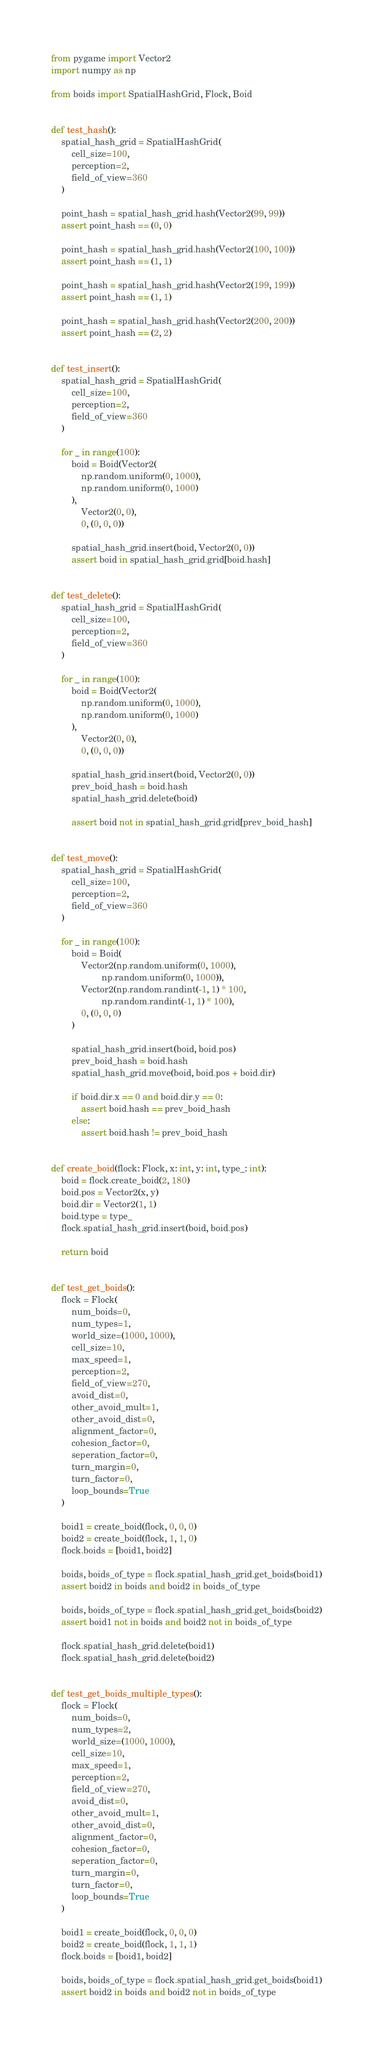<code> <loc_0><loc_0><loc_500><loc_500><_Python_>from pygame import Vector2
import numpy as np

from boids import SpatialHashGrid, Flock, Boid


def test_hash():
    spatial_hash_grid = SpatialHashGrid(
        cell_size=100,
        perception=2,
        field_of_view=360
    )

    point_hash = spatial_hash_grid.hash(Vector2(99, 99))
    assert point_hash == (0, 0)

    point_hash = spatial_hash_grid.hash(Vector2(100, 100))
    assert point_hash == (1, 1)

    point_hash = spatial_hash_grid.hash(Vector2(199, 199))
    assert point_hash == (1, 1)

    point_hash = spatial_hash_grid.hash(Vector2(200, 200))
    assert point_hash == (2, 2)


def test_insert():
    spatial_hash_grid = SpatialHashGrid(
        cell_size=100,
        perception=2,
        field_of_view=360
    )

    for _ in range(100):
        boid = Boid(Vector2(
            np.random.uniform(0, 1000),
            np.random.uniform(0, 1000)
        ),
            Vector2(0, 0),
            0, (0, 0, 0))

        spatial_hash_grid.insert(boid, Vector2(0, 0))
        assert boid in spatial_hash_grid.grid[boid.hash]


def test_delete():
    spatial_hash_grid = SpatialHashGrid(
        cell_size=100,
        perception=2,
        field_of_view=360
    )

    for _ in range(100):
        boid = Boid(Vector2(
            np.random.uniform(0, 1000),
            np.random.uniform(0, 1000)
        ),
            Vector2(0, 0),
            0, (0, 0, 0))

        spatial_hash_grid.insert(boid, Vector2(0, 0))
        prev_boid_hash = boid.hash
        spatial_hash_grid.delete(boid)

        assert boid not in spatial_hash_grid.grid[prev_boid_hash]


def test_move():
    spatial_hash_grid = SpatialHashGrid(
        cell_size=100,
        perception=2,
        field_of_view=360
    )

    for _ in range(100):
        boid = Boid(
            Vector2(np.random.uniform(0, 1000),
                    np.random.uniform(0, 1000)),
            Vector2(np.random.randint(-1, 1) * 100,
                    np.random.randint(-1, 1) * 100),
            0, (0, 0, 0)
        )

        spatial_hash_grid.insert(boid, boid.pos)
        prev_boid_hash = boid.hash
        spatial_hash_grid.move(boid, boid.pos + boid.dir)

        if boid.dir.x == 0 and boid.dir.y == 0:
            assert boid.hash == prev_boid_hash
        else:
            assert boid.hash != prev_boid_hash


def create_boid(flock: Flock, x: int, y: int, type_: int):
    boid = flock.create_boid(2, 180)
    boid.pos = Vector2(x, y)
    boid.dir = Vector2(1, 1)
    boid.type = type_
    flock.spatial_hash_grid.insert(boid, boid.pos)

    return boid


def test_get_boids():
    flock = Flock(
        num_boids=0,
        num_types=1,
        world_size=(1000, 1000),
        cell_size=10,
        max_speed=1,
        perception=2,
        field_of_view=270,
        avoid_dist=0,
        other_avoid_mult=1,
        other_avoid_dist=0,
        alignment_factor=0,
        cohesion_factor=0,
        seperation_factor=0,
        turn_margin=0,
        turn_factor=0,
        loop_bounds=True
    )

    boid1 = create_boid(flock, 0, 0, 0)
    boid2 = create_boid(flock, 1, 1, 0)
    flock.boids = [boid1, boid2]

    boids, boids_of_type = flock.spatial_hash_grid.get_boids(boid1)
    assert boid2 in boids and boid2 in boids_of_type

    boids, boids_of_type = flock.spatial_hash_grid.get_boids(boid2)
    assert boid1 not in boids and boid2 not in boids_of_type

    flock.spatial_hash_grid.delete(boid1)
    flock.spatial_hash_grid.delete(boid2)


def test_get_boids_multiple_types():
    flock = Flock(
        num_boids=0,
        num_types=2,
        world_size=(1000, 1000),
        cell_size=10,
        max_speed=1,
        perception=2,
        field_of_view=270,
        avoid_dist=0,
        other_avoid_mult=1,
        other_avoid_dist=0,
        alignment_factor=0,
        cohesion_factor=0,
        seperation_factor=0,
        turn_margin=0,
        turn_factor=0,
        loop_bounds=True
    )

    boid1 = create_boid(flock, 0, 0, 0)
    boid2 = create_boid(flock, 1, 1, 1)
    flock.boids = [boid1, boid2]

    boids, boids_of_type = flock.spatial_hash_grid.get_boids(boid1)
    assert boid2 in boids and boid2 not in boids_of_type
</code> 